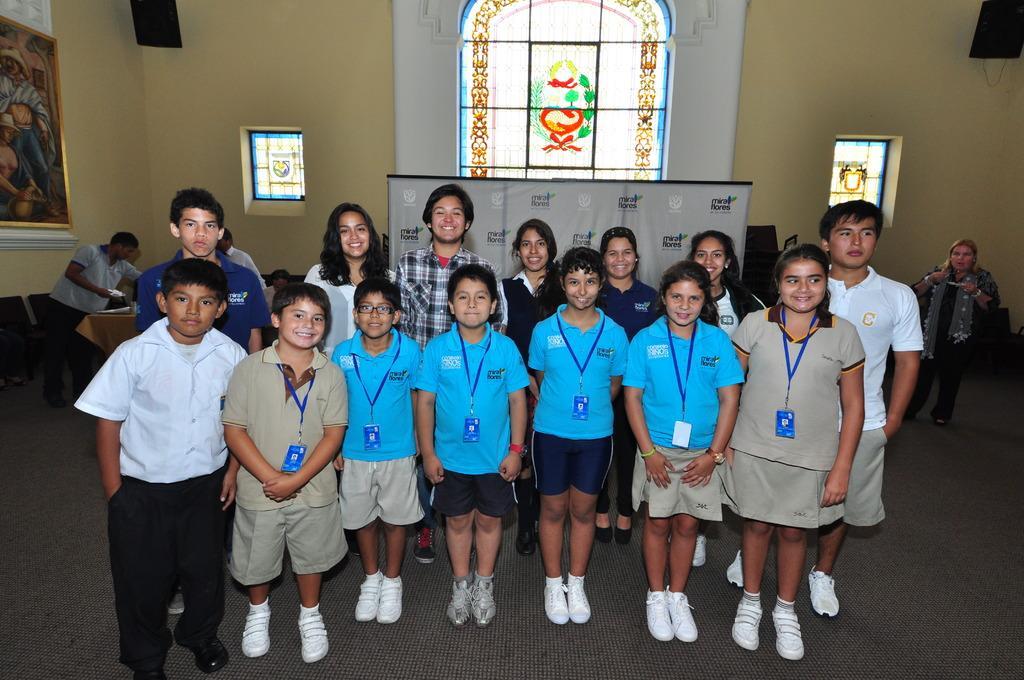Could you give a brief overview of what you see in this image? In this picture I can see a group of children in the middle, in the background there is a banner and there are stained glasses, on the left side I can see some chairs and a photo frame on the wall. On the right side there is a woman. 